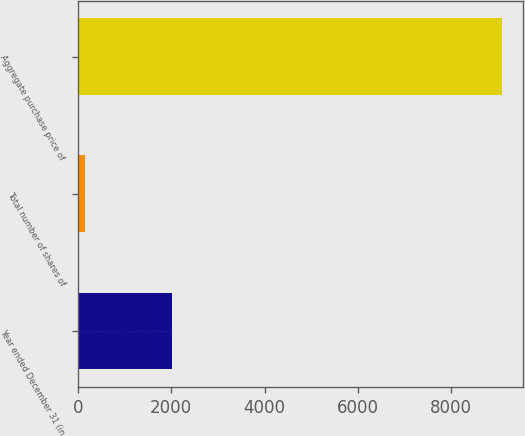Convert chart to OTSL. <chart><loc_0><loc_0><loc_500><loc_500><bar_chart><fcel>Year ended December 31 (in<fcel>Total number of shares of<fcel>Aggregate purchase price of<nl><fcel>2016<fcel>140.4<fcel>9082<nl></chart> 